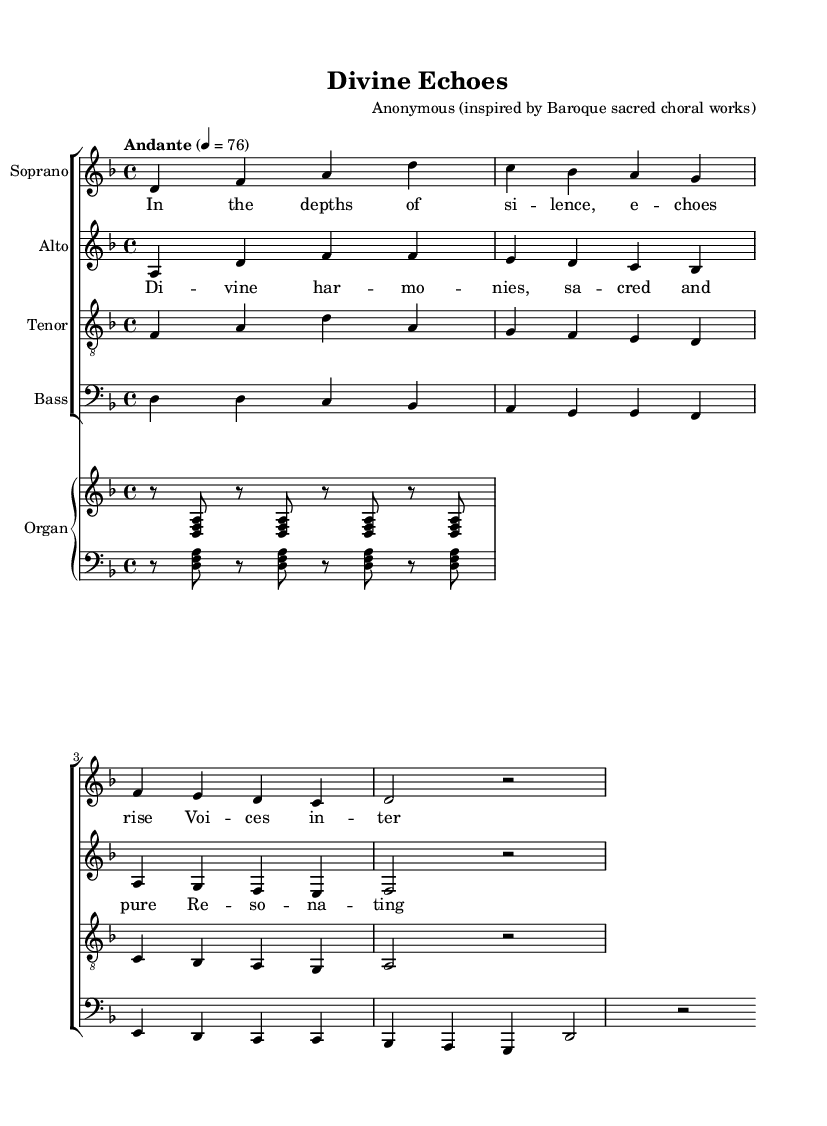What is the key signature of this music? The key signature is indicated by the sharp or flat symbols at the beginning of the staff; in this case, there are no sharps or flats shown, so it is D minor, which has one flat.
Answer: D minor What is the time signature of this music? The time signature is located at the beginning of the staff, indicating how many beats are in each measure; here, it shows 4/4, which means there are 4 beats per measure.
Answer: 4/4 What is the tempo marking of the piece? The tempo marking indicates the speed of the piece, and is shown above the staff; this piece is marked "Andante" with a metronome marking of 76, suggesting a moderately slow pace.
Answer: Andante, 76 How many verses are included in the lyrics? The lyrics are distributed over the music and can be counted; in this score, there are two distinct sections of lyrics labeled as verses and choruses, indicating a total of two.
Answer: Two What is the structure of the piece in terms of vocal parts? The structure can be seen in the organization of the score; this piece features four vocal parts: Soprano, Alto, Tenor, and Bass.
Answer: Four What type of harmonies are utilized in this composition? The piece is classified as a sacred choral work, which typically employs rich and complex harmonies; given the context, the harmonies can be described as divine and powerful.
Answer: Divine harmonies What is the significance of the “organ” in this composition? The organ serves an important role in Baroque music as a primary accompanying instrument, seen in the score where it is indicated to play alongside the choral parts, enhancing the overall harmony and texture.
Answer: Accompanying instrument 